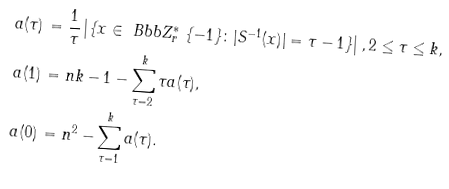<formula> <loc_0><loc_0><loc_500><loc_500>a ( \tau ) \, & = \frac { 1 } { \tau } \left | \{ x \in \ B b b Z _ { r } ^ { * } \ \{ - 1 \} \colon | S ^ { - 1 } ( x ) | = \tau - 1 \} \right | , 2 \leq \tau \leq k , \\ a ( 1 ) \, & = n k - 1 - \sum _ { \tau = 2 } ^ { k } \tau a ( \tau ) , \\ a ( 0 ) \, & = n ^ { 2 } - \sum _ { \tau = 1 } ^ { k } a ( \tau ) .</formula> 